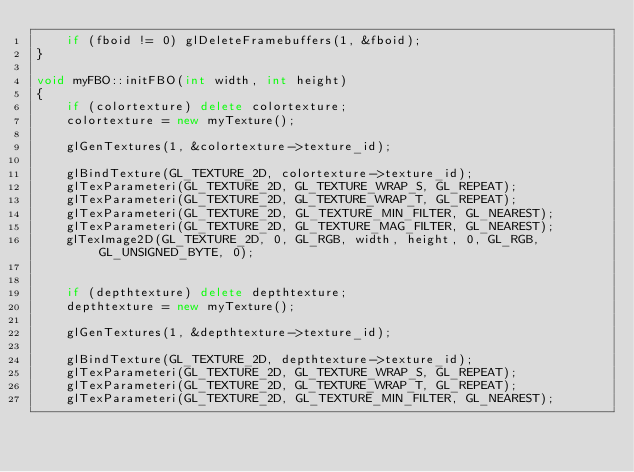<code> <loc_0><loc_0><loc_500><loc_500><_C++_>	if (fboid != 0) glDeleteFramebuffers(1, &fboid);
}

void myFBO::initFBO(int width, int height)
{
	if (colortexture) delete colortexture;
	colortexture = new myTexture();

	glGenTextures(1, &colortexture->texture_id);

	glBindTexture(GL_TEXTURE_2D, colortexture->texture_id);
	glTexParameteri(GL_TEXTURE_2D, GL_TEXTURE_WRAP_S, GL_REPEAT);
	glTexParameteri(GL_TEXTURE_2D, GL_TEXTURE_WRAP_T, GL_REPEAT);
	glTexParameteri(GL_TEXTURE_2D, GL_TEXTURE_MIN_FILTER, GL_NEAREST);
	glTexParameteri(GL_TEXTURE_2D, GL_TEXTURE_MAG_FILTER, GL_NEAREST);
	glTexImage2D(GL_TEXTURE_2D, 0, GL_RGB, width, height, 0, GL_RGB, GL_UNSIGNED_BYTE, 0);


	if (depthtexture) delete depthtexture;
	depthtexture = new myTexture();

	glGenTextures(1, &depthtexture->texture_id);

	glBindTexture(GL_TEXTURE_2D, depthtexture->texture_id);
	glTexParameteri(GL_TEXTURE_2D, GL_TEXTURE_WRAP_S, GL_REPEAT);
	glTexParameteri(GL_TEXTURE_2D, GL_TEXTURE_WRAP_T, GL_REPEAT);
	glTexParameteri(GL_TEXTURE_2D, GL_TEXTURE_MIN_FILTER, GL_NEAREST);</code> 